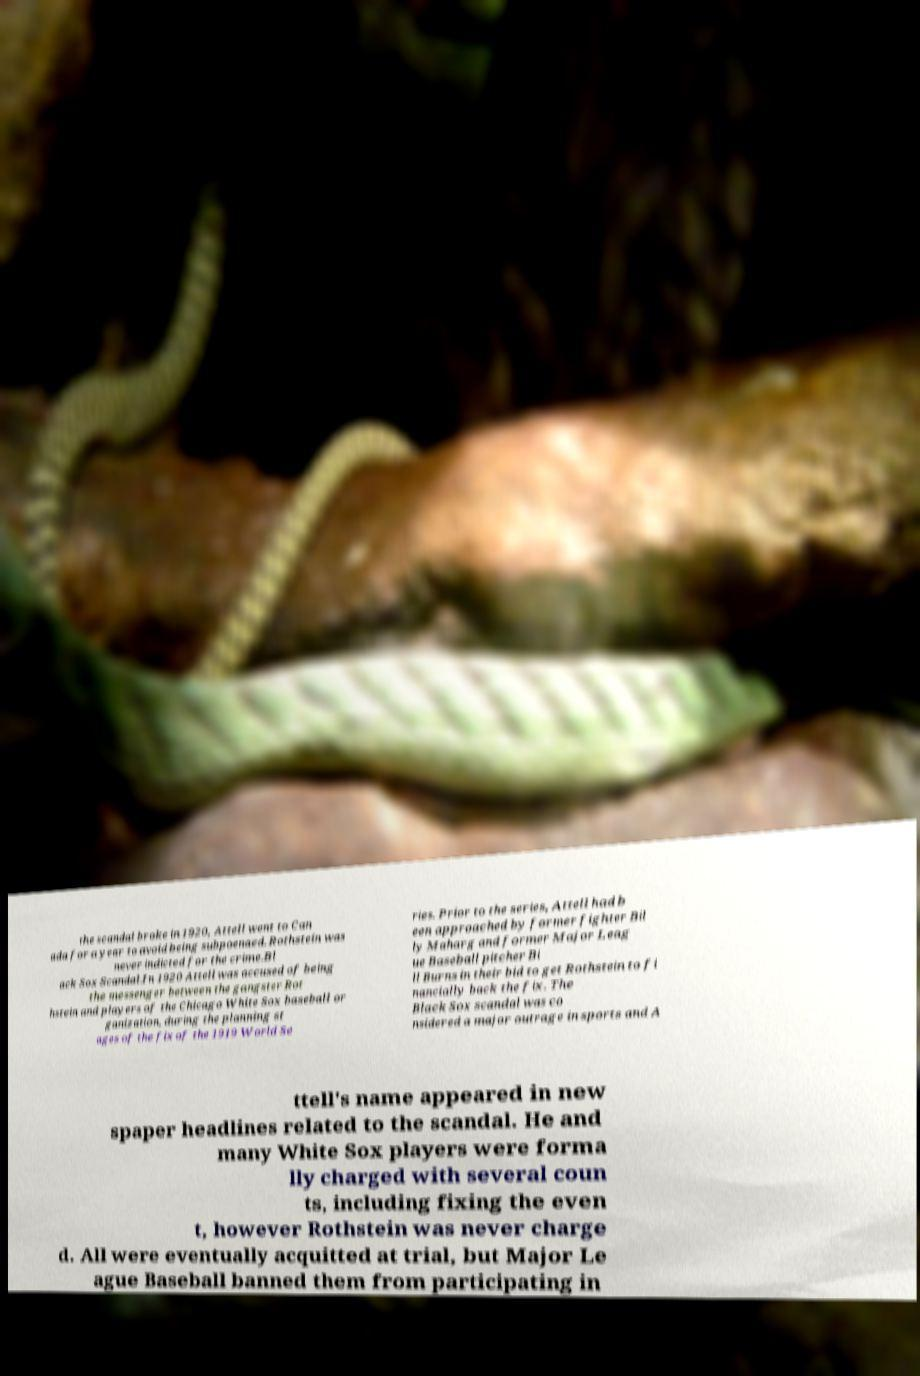There's text embedded in this image that I need extracted. Can you transcribe it verbatim? the scandal broke in 1920, Attell went to Can ada for a year to avoid being subpoenaed. Rothstein was never indicted for the crime.Bl ack Sox Scandal.In 1920 Attell was accused of being the messenger between the gangster Rot hstein and players of the Chicago White Sox baseball or ganization, during the planning st ages of the fix of the 1919 World Se ries. Prior to the series, Attell had b een approached by former fighter Bil ly Maharg and former Major Leag ue Baseball pitcher Bi ll Burns in their bid to get Rothstein to fi nancially back the fix. The Black Sox scandal was co nsidered a major outrage in sports and A ttell's name appeared in new spaper headlines related to the scandal. He and many White Sox players were forma lly charged with several coun ts, including fixing the even t, however Rothstein was never charge d. All were eventually acquitted at trial, but Major Le ague Baseball banned them from participating in 